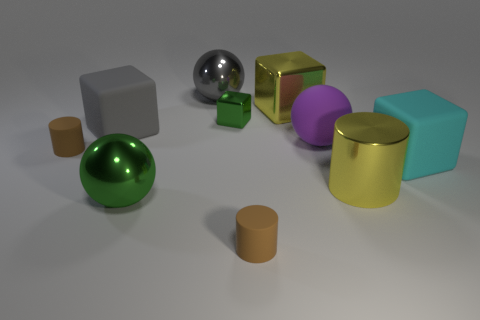Are there fewer purple objects behind the gray matte object than small purple objects?
Make the answer very short. No. How many matte things are either large cylinders or big purple balls?
Make the answer very short. 1. Is the color of the rubber sphere the same as the shiny cylinder?
Your answer should be compact. No. Is there any other thing that is the same color as the big metallic block?
Offer a very short reply. Yes. There is a gray object that is in front of the big gray metal ball; is it the same shape as the green metal object that is left of the gray metal thing?
Provide a short and direct response. No. How many things are big green rubber cylinders or tiny brown rubber objects that are to the left of the large gray rubber thing?
Your response must be concise. 1. What number of other things are the same size as the gray matte block?
Your response must be concise. 6. Is the tiny brown thing in front of the large cyan block made of the same material as the green thing that is in front of the small green metal object?
Provide a short and direct response. No. There is a gray rubber thing; what number of brown matte cylinders are in front of it?
Make the answer very short. 2. What number of green objects are matte things or metallic cubes?
Your answer should be very brief. 1. 